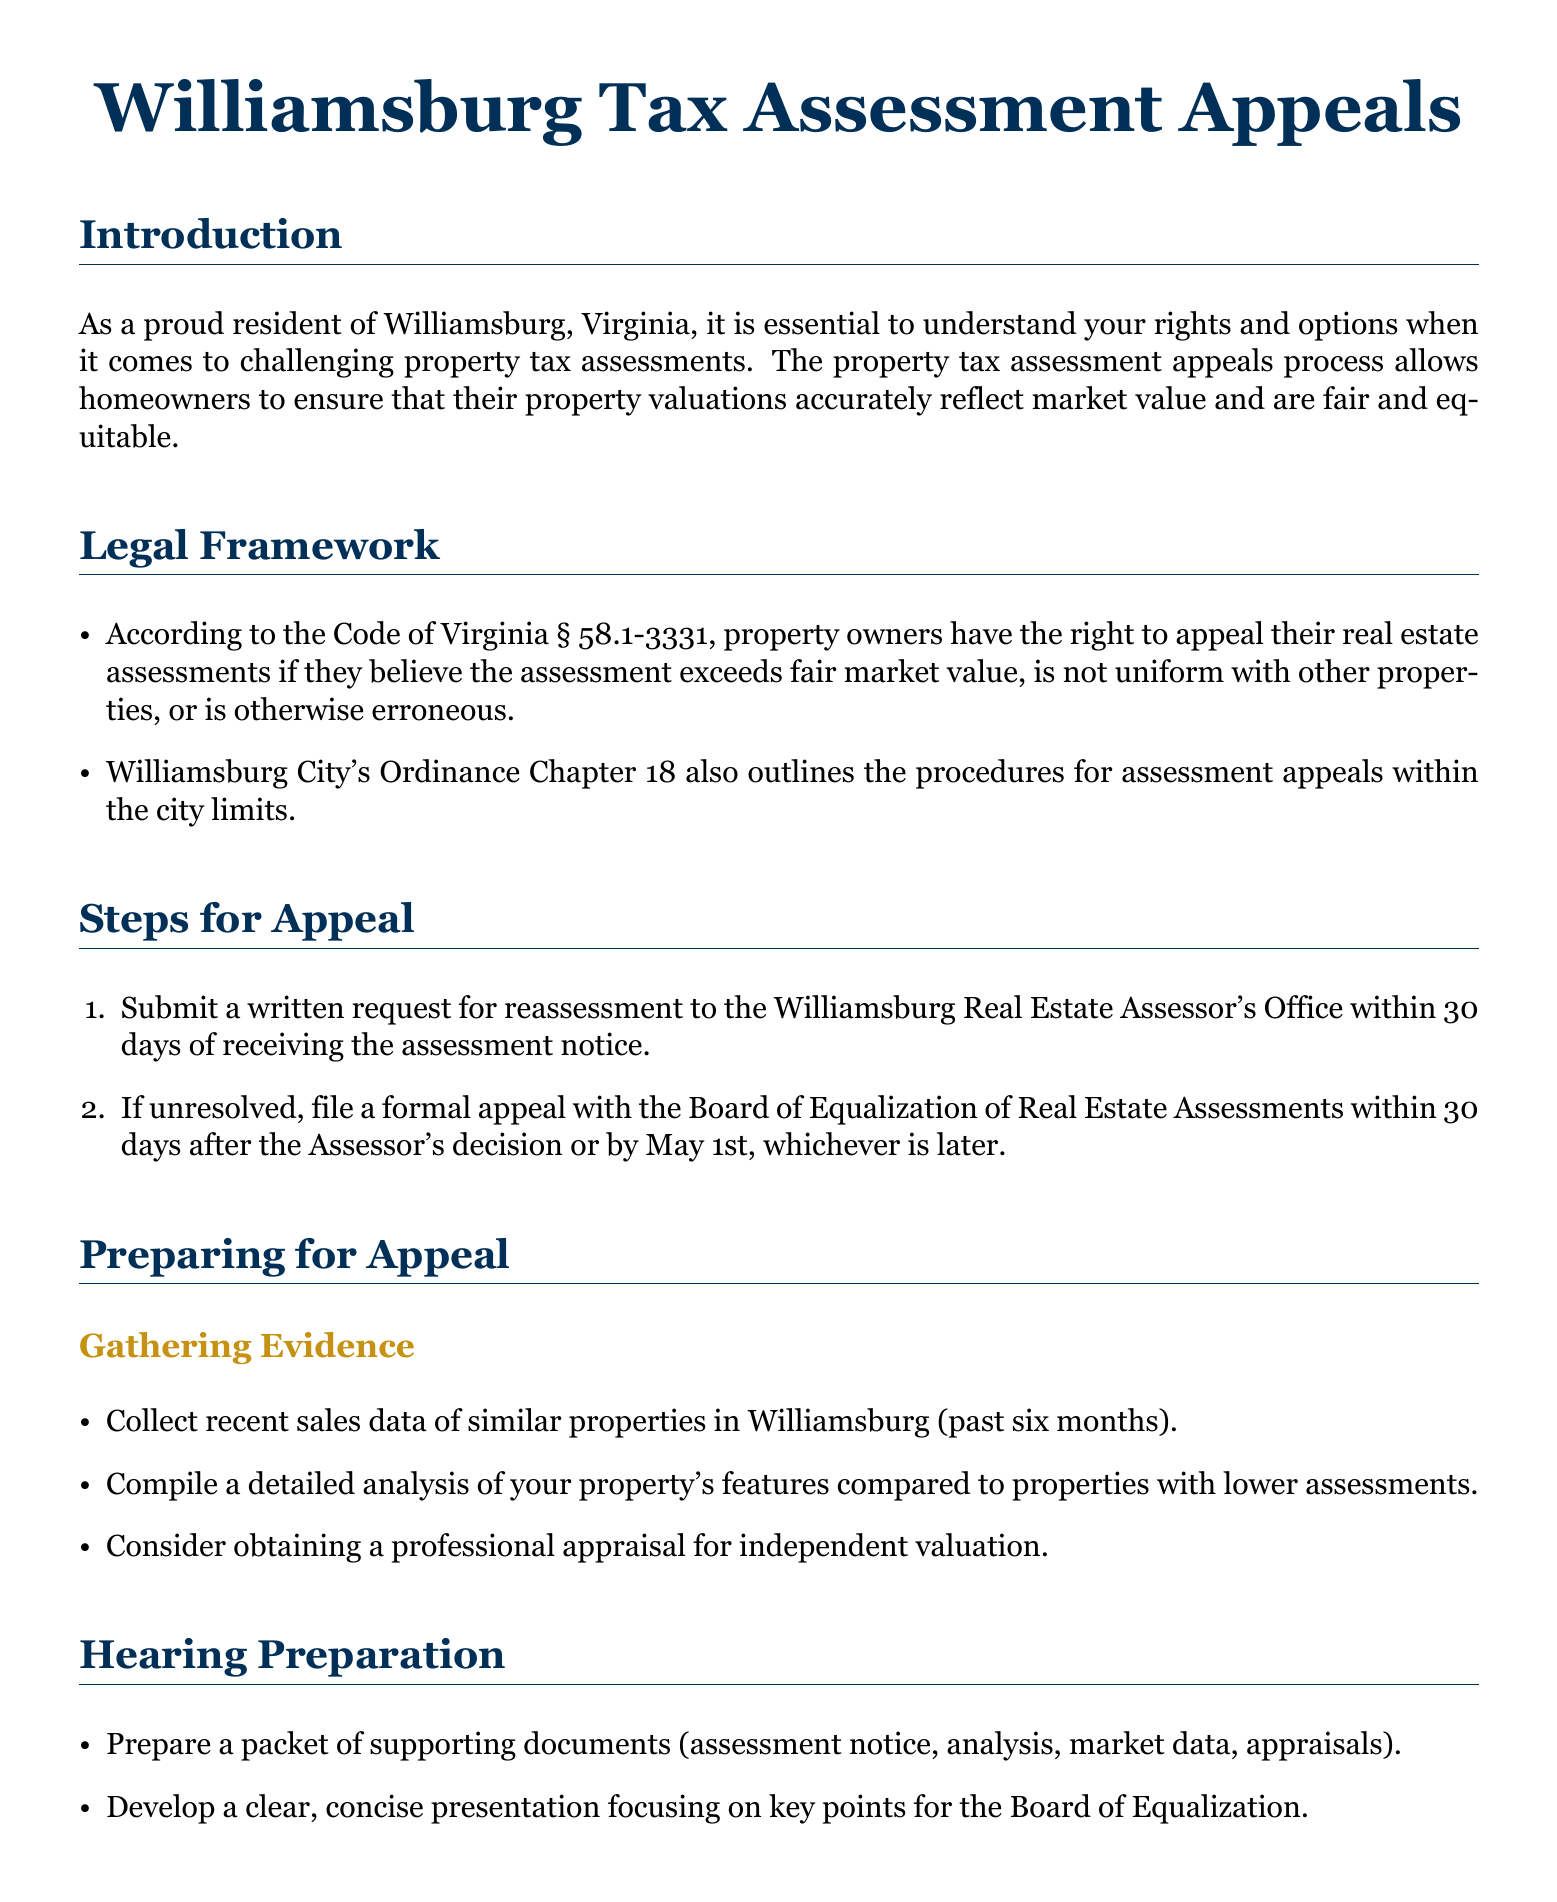What is the time limit to submit a written request for reassessment? The time limit to submit a written request for reassessment is 30 days after receiving the assessment notice.
Answer: 30 days What is the address of the Williamsburg Real Estate Assessor's Office? The address is found in the contact information section of the document.
Answer: 401 Lafayette St, Williamsburg, VA 23185 What legal document outlines property owners' rights to appeal assessments? The legal framework section mentions a specific section of the Code of Virginia.
Answer: Code of Virginia § 58.1-3331 What may the Board of Equalization decide regarding an assessment? The potential outcomes section details the possible decisions of the Board.
Answer: Reduce, unchanged, or increase What type of evidence should be collected when preparing for an appeal? The document specifies that recent sales data of similar properties should be gathered.
Answer: Recent sales data What is a recommended step for hearing preparation? The hearing preparation section advises developing a clear presentation.
Answer: Develop a clear presentation What website can be visited for more information about the Board of Equalization? The website is listed in the contact information section for the Board of Equalization.
Answer: williamsburgva.gov When is the deadline to file a formal appeal with the Board of Equalization if the Assessor's decision is unresolved? The steps for appeal section indicates the deadline is either 30 days after the Assessor's decision or by May 1st.
Answer: May 1st 